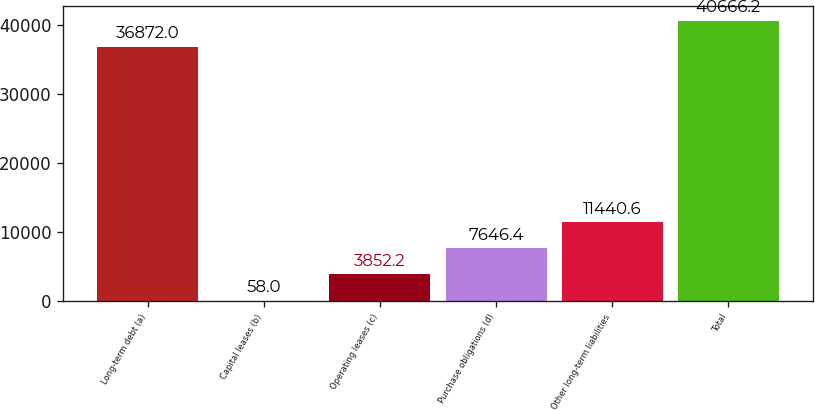<chart> <loc_0><loc_0><loc_500><loc_500><bar_chart><fcel>Long-term debt (a)<fcel>Capital leases (b)<fcel>Operating leases (c)<fcel>Purchase obligations (d)<fcel>Other long-term liabilities<fcel>Total<nl><fcel>36872<fcel>58<fcel>3852.2<fcel>7646.4<fcel>11440.6<fcel>40666.2<nl></chart> 